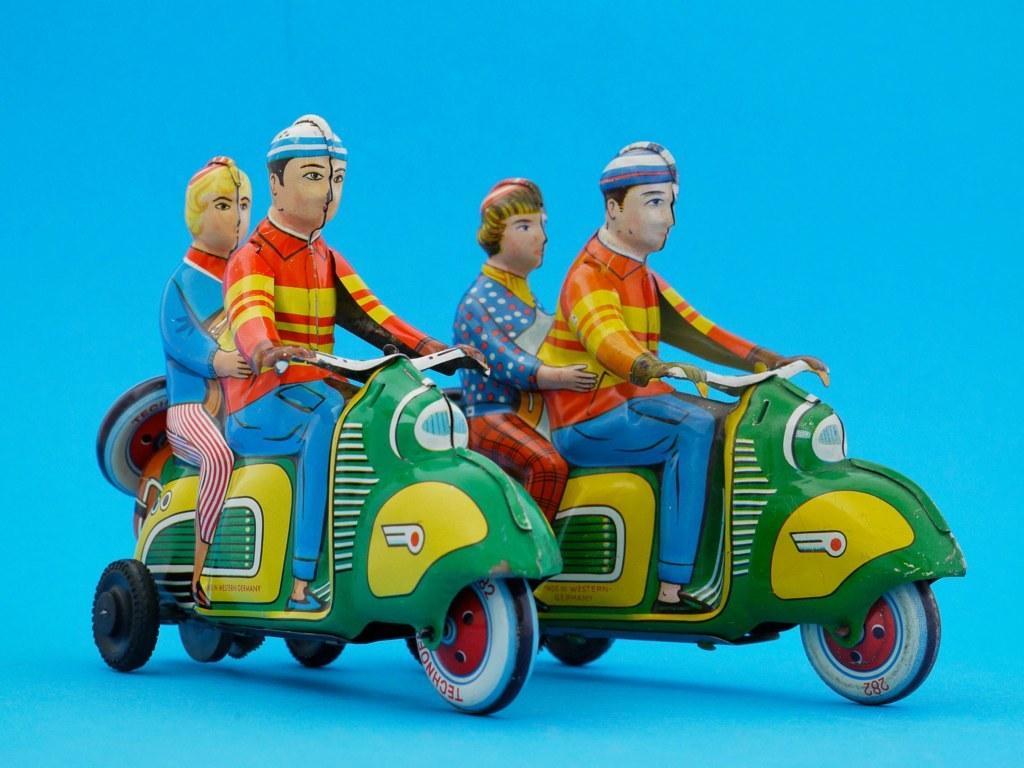Can you describe this image briefly? In this picture we can see two men riding scooters and two people sitting at the back of them. 